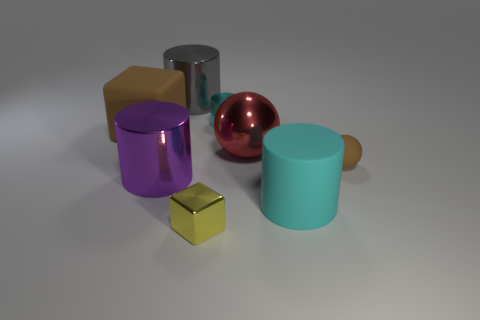What number of things are either tiny purple shiny things or big objects?
Your answer should be very brief. 5. How many rubber objects are on the left side of the cyan thing in front of the big shiny cylinder that is in front of the big cube?
Provide a short and direct response. 1. Is there anything else that is the same color as the big rubber cube?
Offer a very short reply. Yes. Is the color of the matte thing to the left of the cyan rubber cylinder the same as the small rubber sphere that is to the right of the large cyan matte thing?
Provide a short and direct response. Yes. Are there more rubber objects right of the large purple cylinder than yellow metal objects behind the tiny yellow cube?
Ensure brevity in your answer.  Yes. What is the large red sphere made of?
Your answer should be compact. Metal. There is a brown rubber object that is to the right of the large brown rubber thing that is left of the large metal thing that is on the right side of the small cylinder; what shape is it?
Ensure brevity in your answer.  Sphere. How many other things are there of the same material as the brown block?
Make the answer very short. 2. Do the cube behind the purple shiny cylinder and the block that is to the right of the big purple metal cylinder have the same material?
Offer a very short reply. No. What number of things are right of the cyan matte thing and left of the red sphere?
Your answer should be compact. 0. 